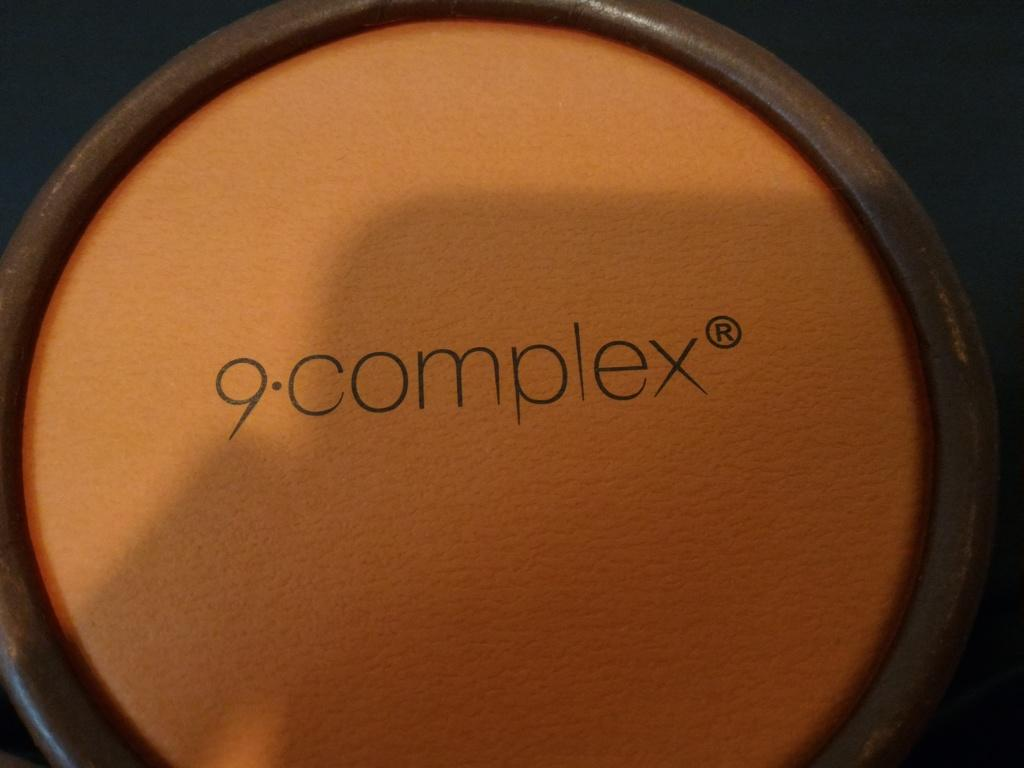<image>
Write a terse but informative summary of the picture. A circular object that has 9 complex written on it. 